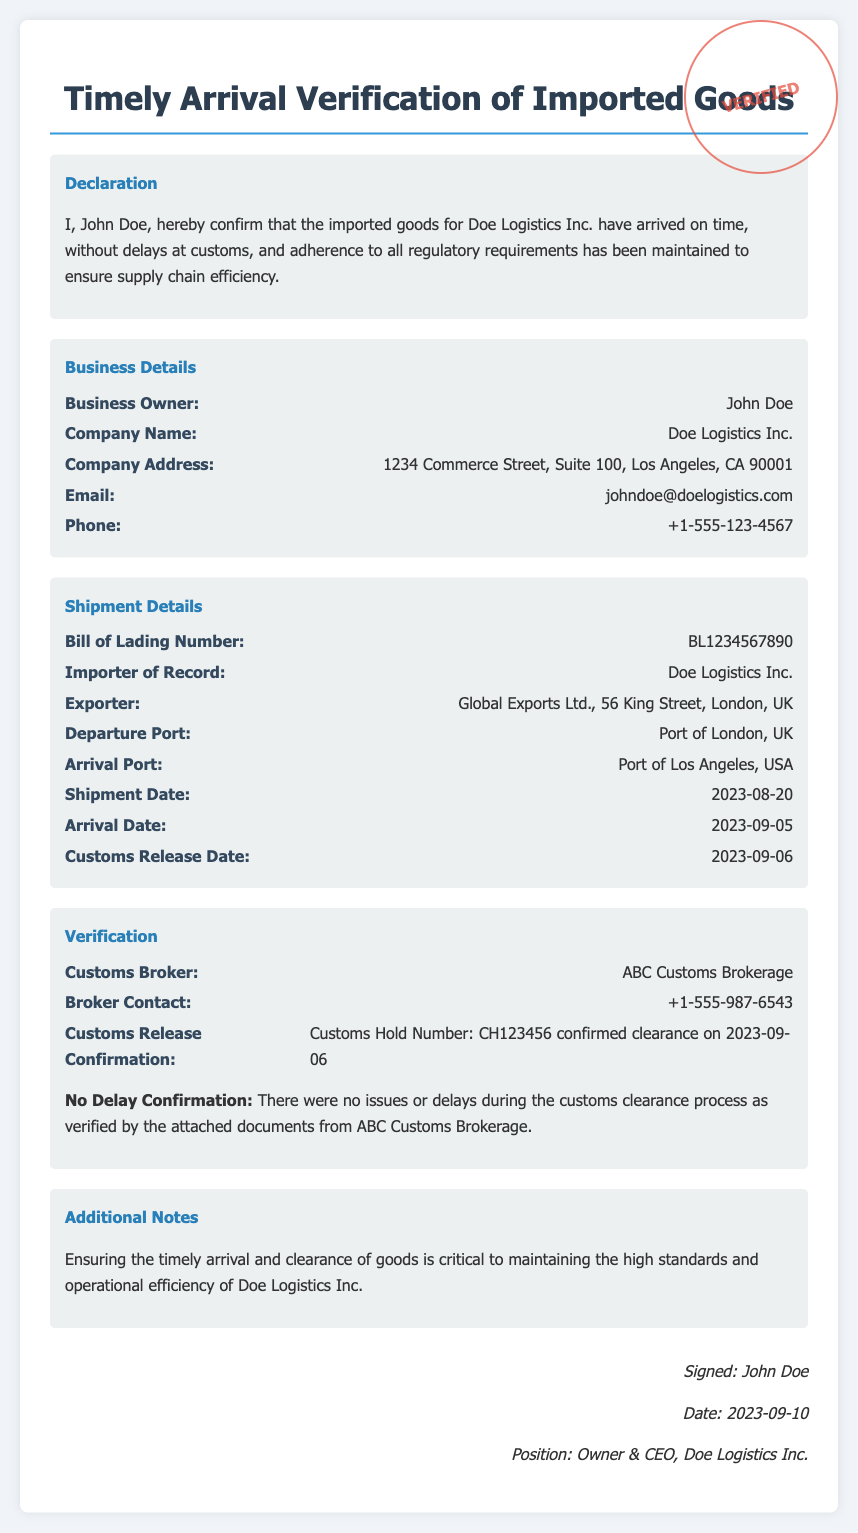What is the name of the business owner? The document states that the business owner is John Doe.
Answer: John Doe What is the company name? The document specifies that the company name is Doe Logistics Inc.
Answer: Doe Logistics Inc What is the shipment date? The document indicates the shipment date as 2023-08-20.
Answer: 2023-08-20 What is the arrival date? The document specifies the arrival date of the goods as 2023-09-05.
Answer: 2023-09-05 What is the customs release date? According to the document, the customs release date is 2023-09-06.
Answer: 2023-09-06 What is the Bill of Lading number? The document mentions the Bill of Lading number as BL1234567890.
Answer: BL1234567890 Who is the customs broker? It is stated in the document that the customs broker is ABC Customs Brokerage.
Answer: ABC Customs Brokerage What is confirmed in the no delay confirmation? The document confirms that there were no issues or delays during the customs clearance process.
Answer: No issues or delays When was the declaration signed? The document reveals that the declaration was signed on 2023-09-10.
Answer: 2023-09-10 